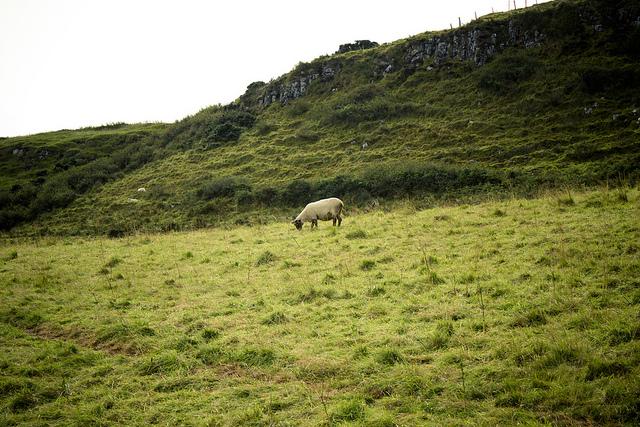How many sheep are in the picture?
Quick response, please. 1. How many animals?
Keep it brief. 1. Is he grazing?
Keep it brief. Yes. Is this animal alone?
Give a very brief answer. Yes. Is it a gloomy day?
Keep it brief. No. How many sheep are on the hillside?
Keep it brief. 1. Is there a lake?
Write a very short answer. No. Is there green in this image?
Be succinct. Yes. What objects are in the grass?
Give a very brief answer. Sheep. What is the weather like in this scene?
Concise answer only. Sunny. 